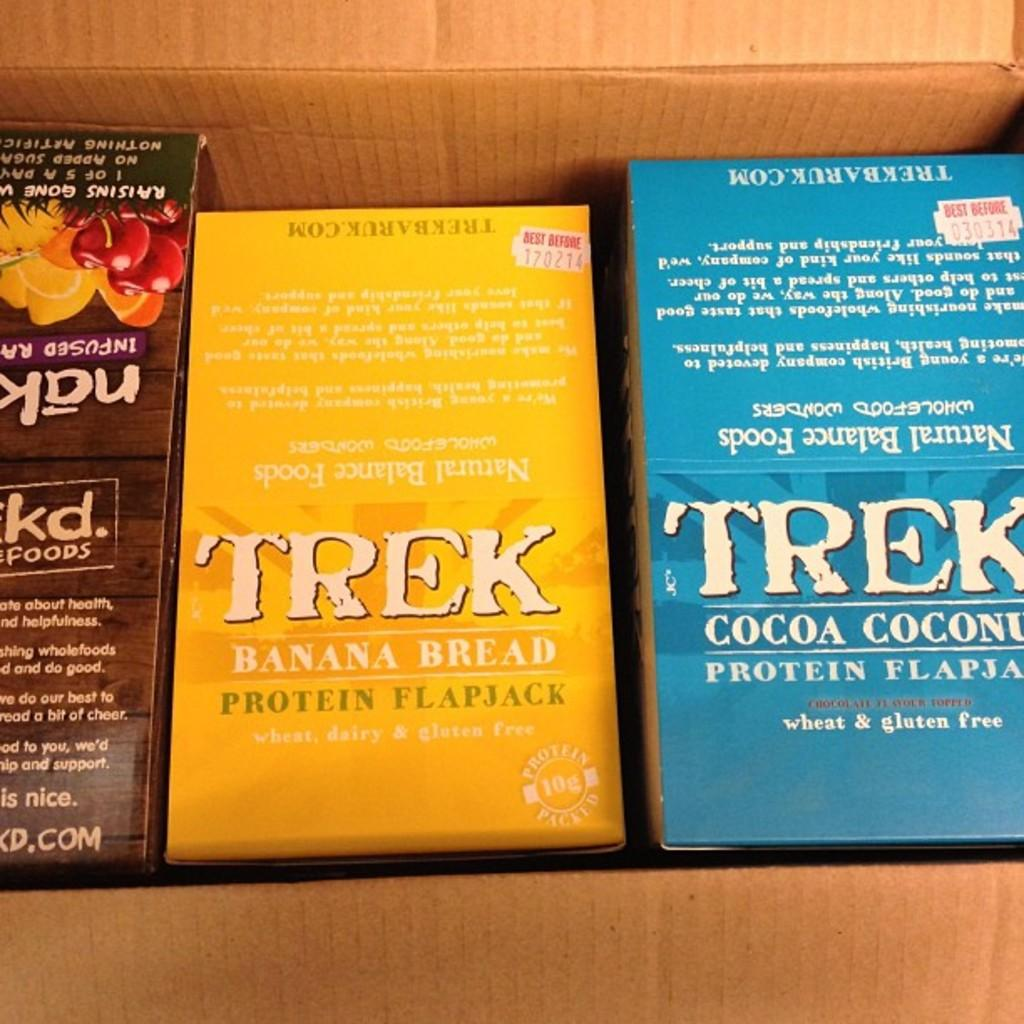<image>
Create a compact narrative representing the image presented. Cardboard box of boxed baking supplies including Trek banana bread and cocoa coconut protein flapjacks. 